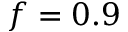<formula> <loc_0><loc_0><loc_500><loc_500>f = 0 . 9</formula> 